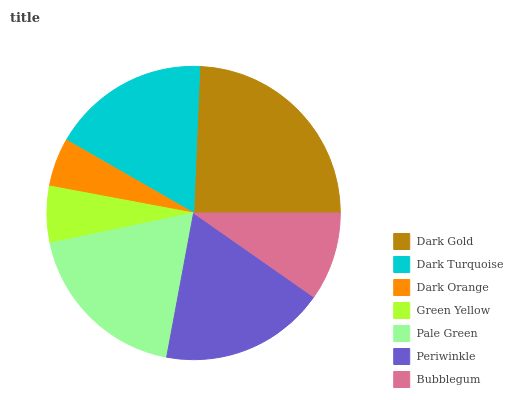Is Dark Orange the minimum?
Answer yes or no. Yes. Is Dark Gold the maximum?
Answer yes or no. Yes. Is Dark Turquoise the minimum?
Answer yes or no. No. Is Dark Turquoise the maximum?
Answer yes or no. No. Is Dark Gold greater than Dark Turquoise?
Answer yes or no. Yes. Is Dark Turquoise less than Dark Gold?
Answer yes or no. Yes. Is Dark Turquoise greater than Dark Gold?
Answer yes or no. No. Is Dark Gold less than Dark Turquoise?
Answer yes or no. No. Is Dark Turquoise the high median?
Answer yes or no. Yes. Is Dark Turquoise the low median?
Answer yes or no. Yes. Is Bubblegum the high median?
Answer yes or no. No. Is Dark Orange the low median?
Answer yes or no. No. 